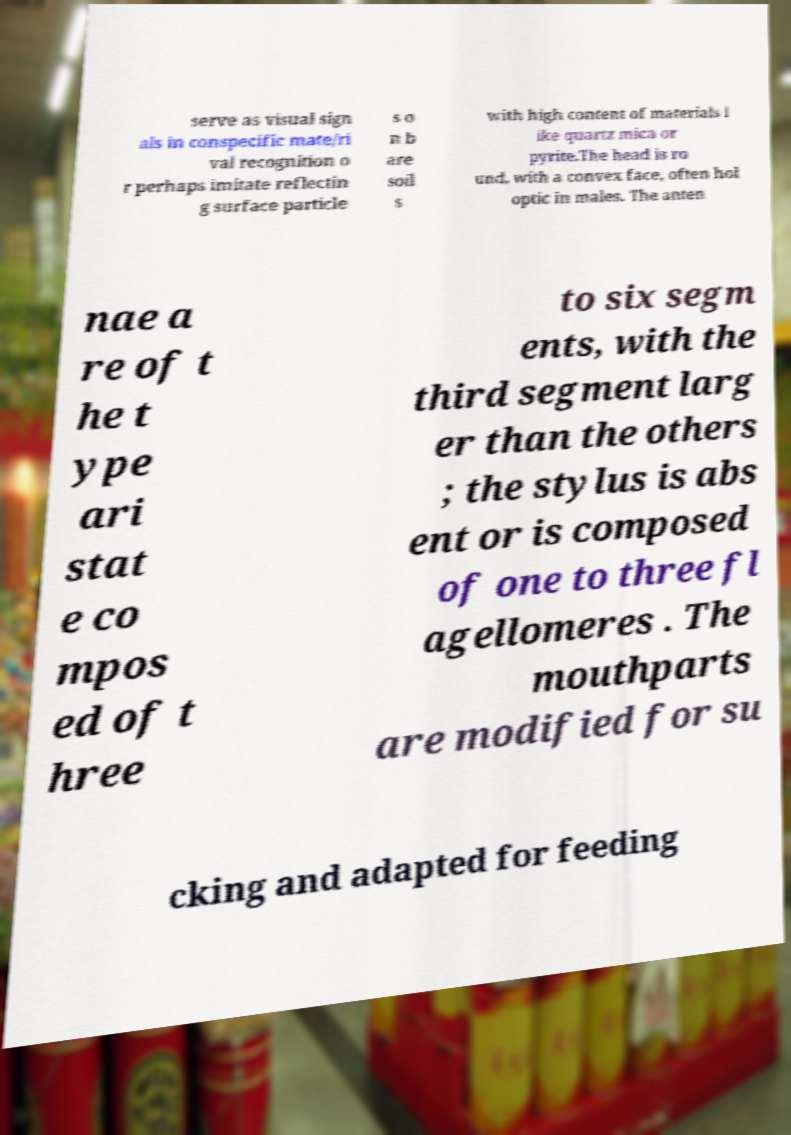Could you assist in decoding the text presented in this image and type it out clearly? serve as visual sign als in conspecific mate/ri val recognition o r perhaps imitate reflectin g surface particle s o n b are soil s with high content of materials l ike quartz mica or pyrite.The head is ro und, with a convex face, often hol optic in males. The anten nae a re of t he t ype ari stat e co mpos ed of t hree to six segm ents, with the third segment larg er than the others ; the stylus is abs ent or is composed of one to three fl agellomeres . The mouthparts are modified for su cking and adapted for feeding 